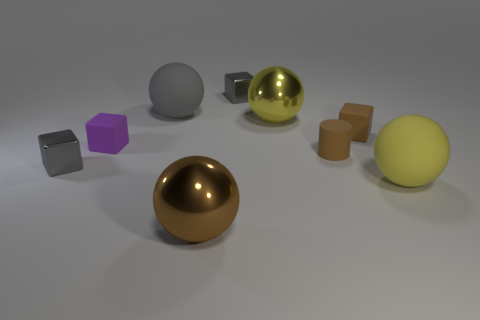Subtract all cyan blocks. Subtract all red spheres. How many blocks are left? 4 Add 1 metal things. How many objects exist? 10 Subtract all blocks. How many objects are left? 5 Add 6 big spheres. How many big spheres exist? 10 Subtract 0 red balls. How many objects are left? 9 Subtract all blue metallic things. Subtract all brown matte cylinders. How many objects are left? 8 Add 8 large brown metallic things. How many large brown metallic things are left? 9 